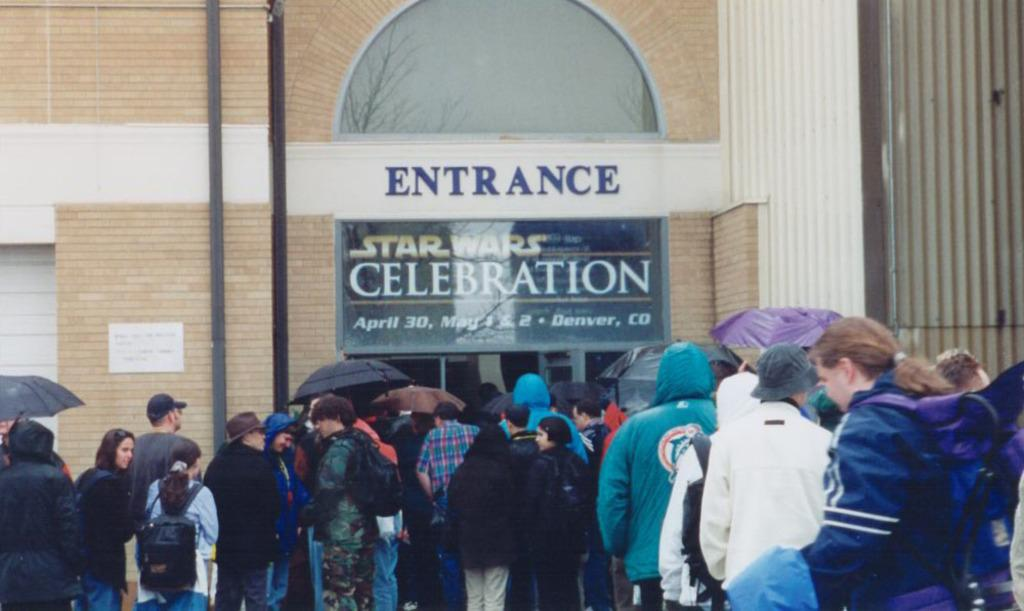What is happening in front of the building in the image? There are persons standing in front of a building. Can you describe the building? The building has an entrance and "Star Wars Celebration" written on it. What type of honey is being used to decorate the building in the image? There is no honey present in the image; the building has "Star Wars Celebration" written on it. How many spiders are crawling on the persons standing in front of the building? There are no spiders present in the image; it only shows persons standing in front of a building. 